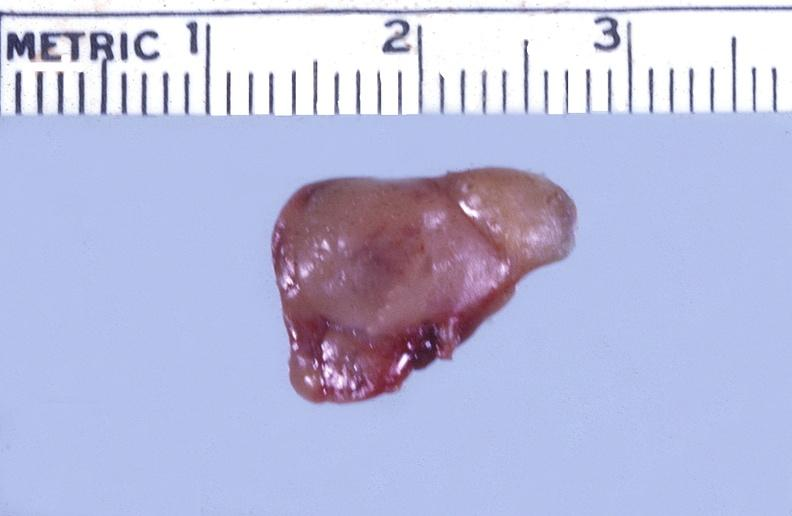what does this image show?
Answer the question using a single word or phrase. Parathyroid 